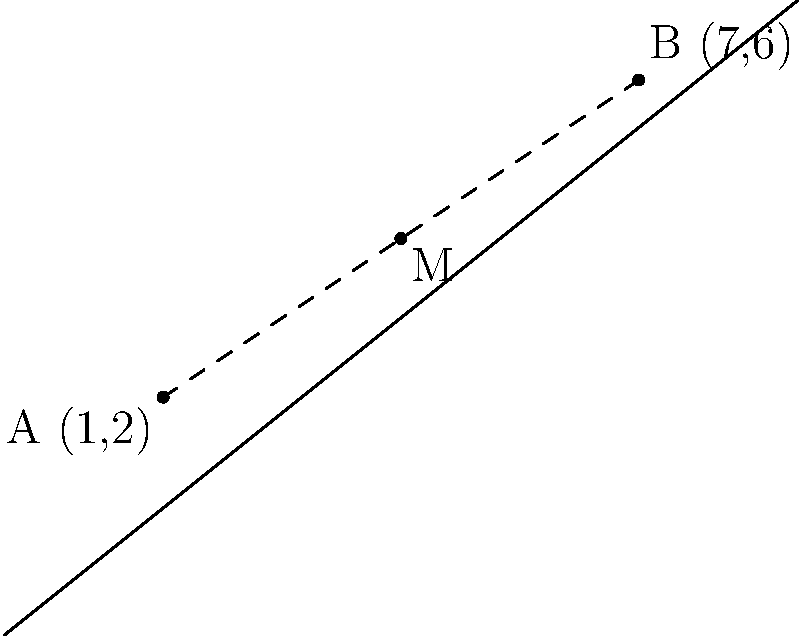At the Gazpacho concert arena, two merchandise stands are located at coordinates (1,2) and (7,6). As a superfan, you want to find the ideal spot to quickly access both stands. What are the coordinates of the point that is equidistant from both merchandise stands? To find the point that is equidistant from both merchandise stands, we need to calculate the midpoint of the line segment connecting the two stands. Here's how to do it:

1. Identify the coordinates:
   Stand A: $(x_1, y_1) = (1, 2)$
   Stand B: $(x_2, y_2) = (7, 6)$

2. Use the midpoint formula:
   $M_x = \frac{x_1 + x_2}{2}$
   $M_y = \frac{y_1 + y_2}{2}$

3. Calculate $M_x$:
   $M_x = \frac{1 + 7}{2} = \frac{8}{2} = 4$

4. Calculate $M_y$:
   $M_y = \frac{2 + 6}{2} = \frac{8}{2} = 4$

5. The midpoint M is $(M_x, M_y) = (4, 4)$

Therefore, the coordinates of the point equidistant from both merchandise stands are (4,4).
Answer: (4,4) 